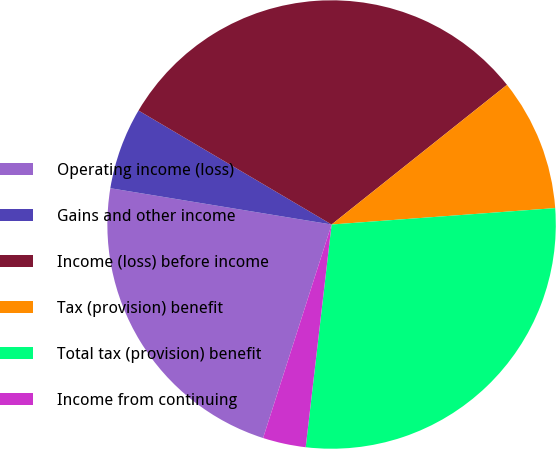Convert chart. <chart><loc_0><loc_0><loc_500><loc_500><pie_chart><fcel>Operating income (loss)<fcel>Gains and other income<fcel>Income (loss) before income<fcel>Tax (provision) benefit<fcel>Total tax (provision) benefit<fcel>Income from continuing<nl><fcel>22.65%<fcel>5.9%<fcel>30.81%<fcel>9.54%<fcel>28.01%<fcel>3.1%<nl></chart> 